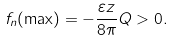Convert formula to latex. <formula><loc_0><loc_0><loc_500><loc_500>f _ { n } ( \max ) = - \frac { \varepsilon z } { 8 \pi } Q > 0 .</formula> 